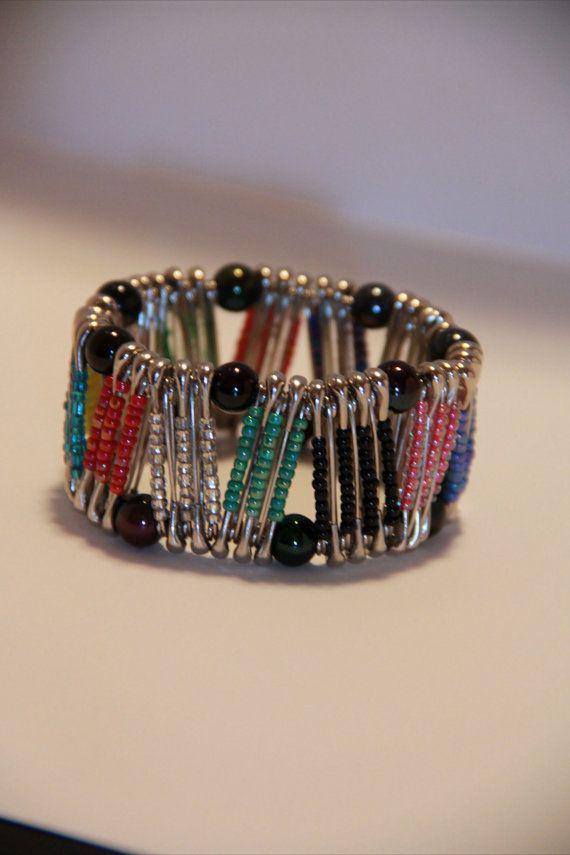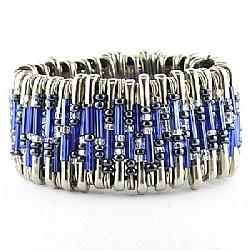The first image is the image on the left, the second image is the image on the right. Evaluate the accuracy of this statement regarding the images: "In the left image, all beads are tans, blacks, whites and oranges.". Is it true? Answer yes or no. No. The first image is the image on the left, the second image is the image on the right. Given the left and right images, does the statement "Each image contains one bracelet constructed of rows of vertical beaded safety pins, and no bracelet has a watch face." hold true? Answer yes or no. Yes. 